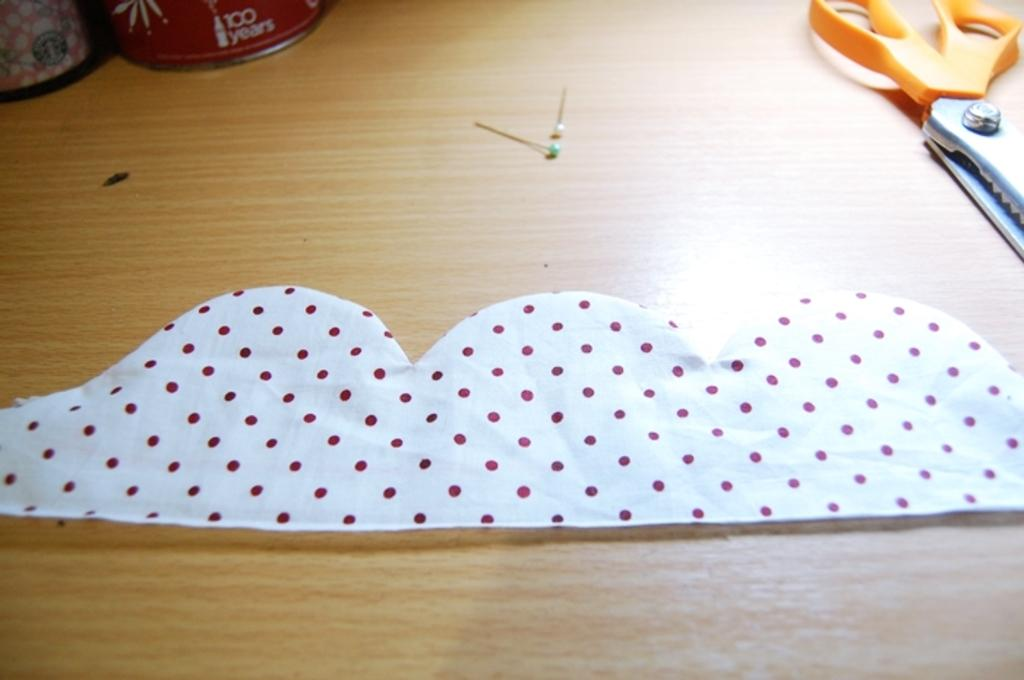What color is the cloth in the image? The cloth in the image is white. What cutting tool is present in the image? There are scissors in the image. What type of fasteners can be seen in the image? There are head pins in the image. What are the colors of the boxes in the image? There is a red box and a cream-colored box in the image. On what surface are the objects placed? The objects are placed on a wooden table. How many rabbits are sitting on the wooden table in the image? There are no rabbits present in the image; the objects on the table include a white cloth, scissors, head pins, a red box, and a cream-colored box. 